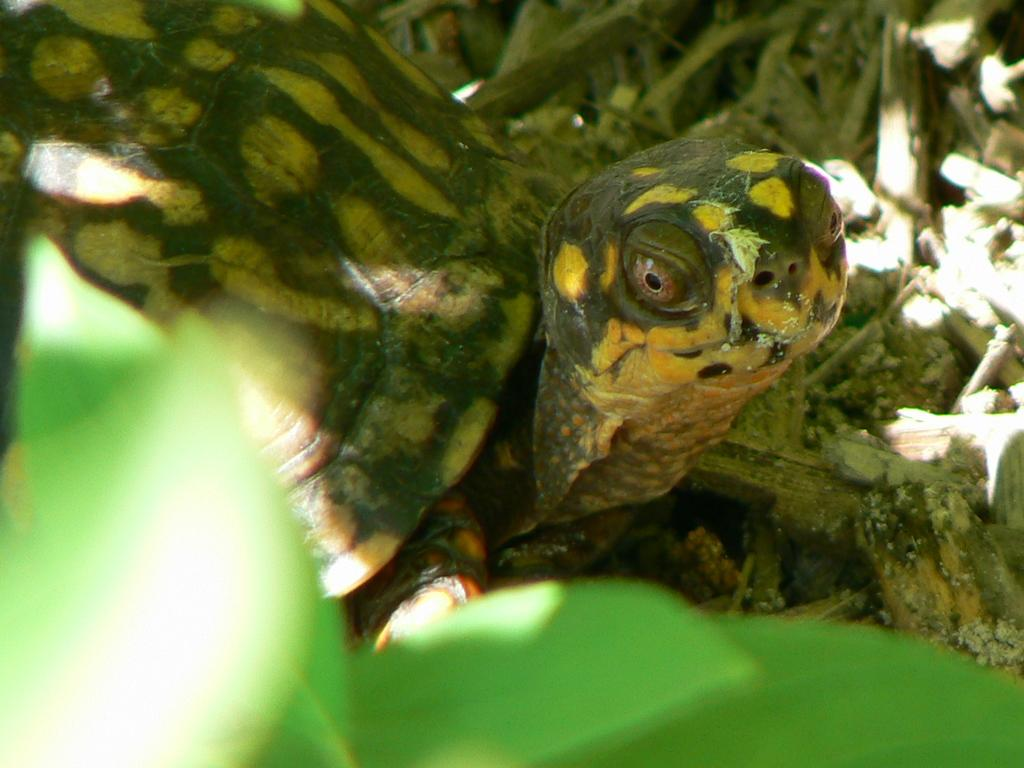What animal can be seen in the image? There is a tortoise in the image. Where is the tortoise located in the image? The tortoise is on the ground. What type of terrain is visible in the image? There is grass on the ground in the image. Can you describe the objects in the front of the image? Leaves are visible in the front of the image, but they are blurry. How many fingers can be seen on the tortoise's hand in the image? Tortoises do not have hands or fingers; they have feet with claws. --- Facts: 1. There is a person holding a camera in the image. 2. The person is standing on a bridge. 3. The bridge is over a river. 4. There are trees on both sides of the river. 5. The sky is visible in the image. Absurd Topics: elephant, piano, dance Conversation: What is the person in the image doing? The person is holding a camera in the image. Where is the person standing in the image? The person is standing on a bridge. What is the bridge positioned over in the image? The bridge is over a river. What type of vegetation can be seen near the river in the image? There are trees on both sides of the river. What can be seen in the sky in the image? The sky is visible in the image. Reasoning: Let's think step by step in order to produce the conversation. We start by identifying the main subject in the image, which is the person holding a camera. Then, we expand the conversation to include the person's location on the bridge and the bridge's position over the river. Next, we mention the trees on both sides of the river and the visibility of the sky in the image. Absurd Question/Answer: Can you tell me where the piano is located in the image? There is no piano present in the image. Is the person in the image dancing while holding the camera? The image does not show the person dancing; they are simply holding a camera. 